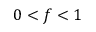<formula> <loc_0><loc_0><loc_500><loc_500>0 < f < 1</formula> 